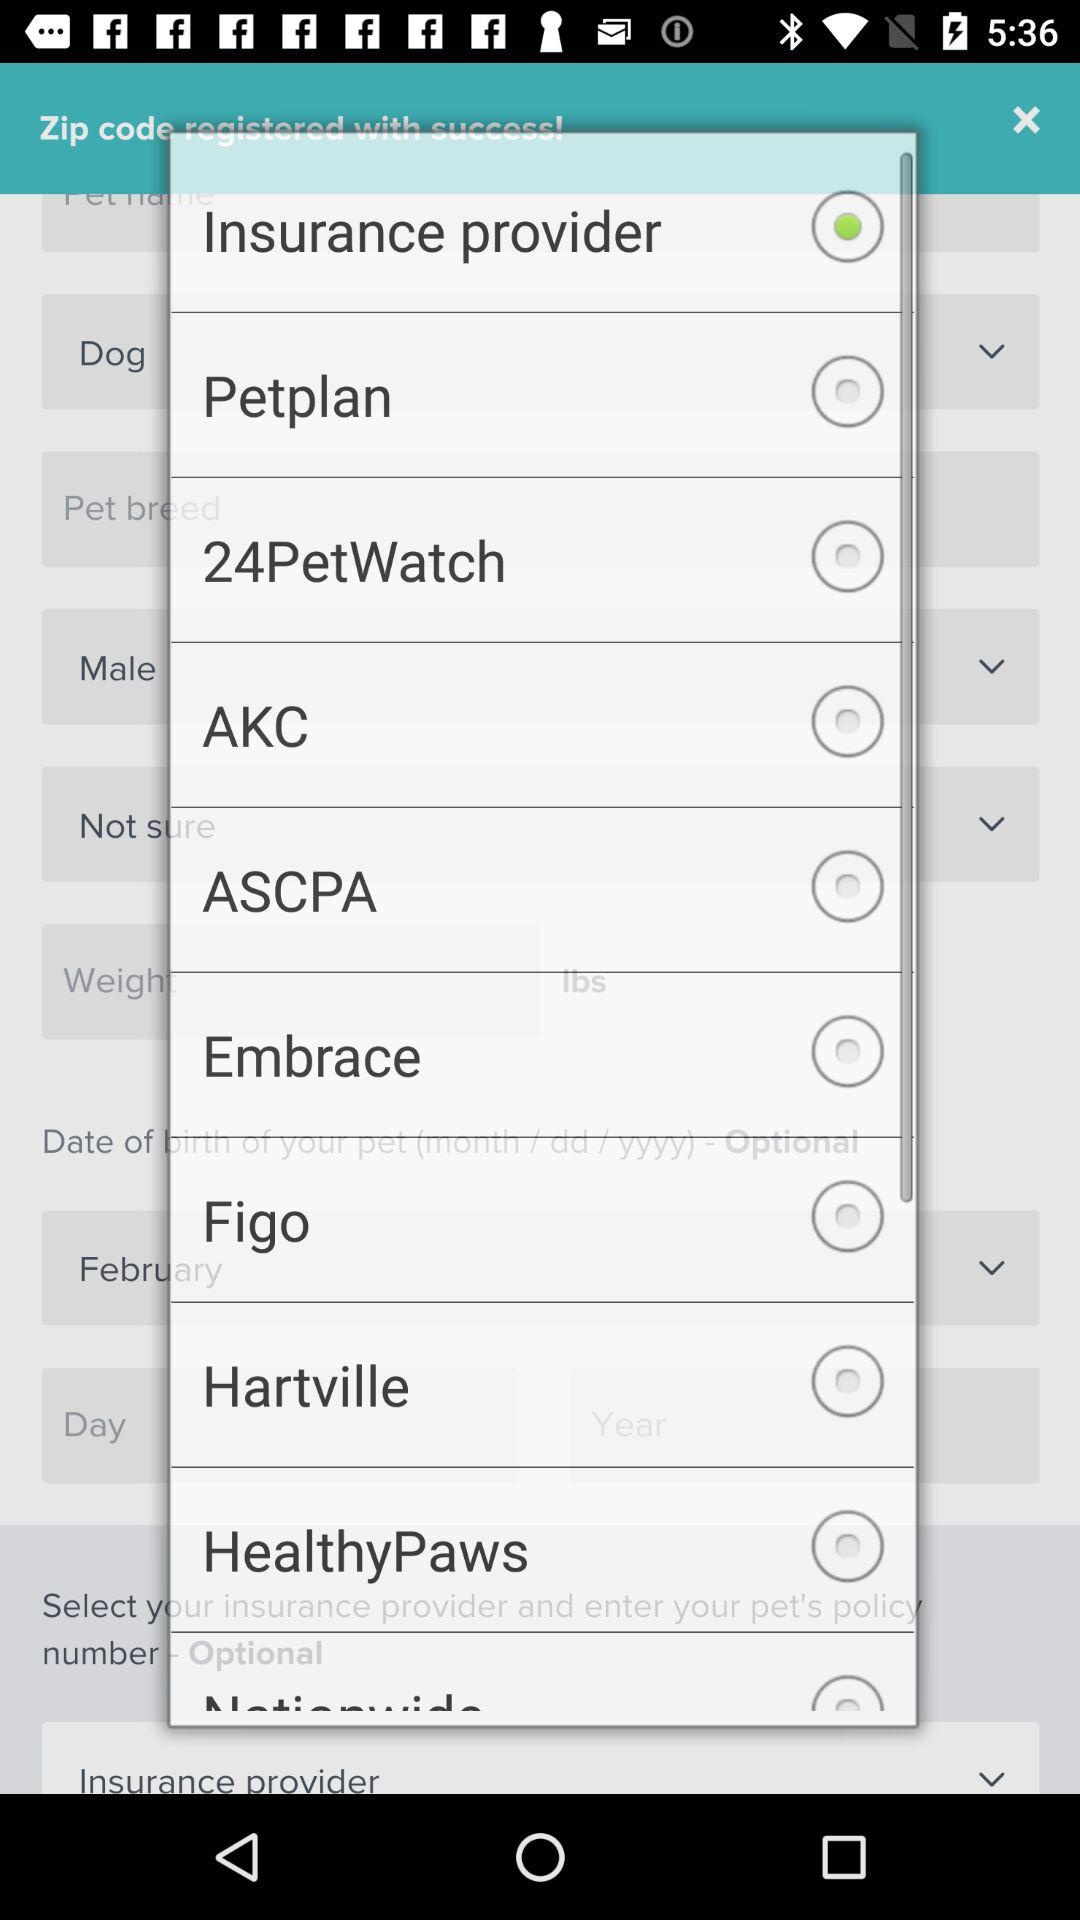Which option is selected? The selected option is "Insurance provider". 